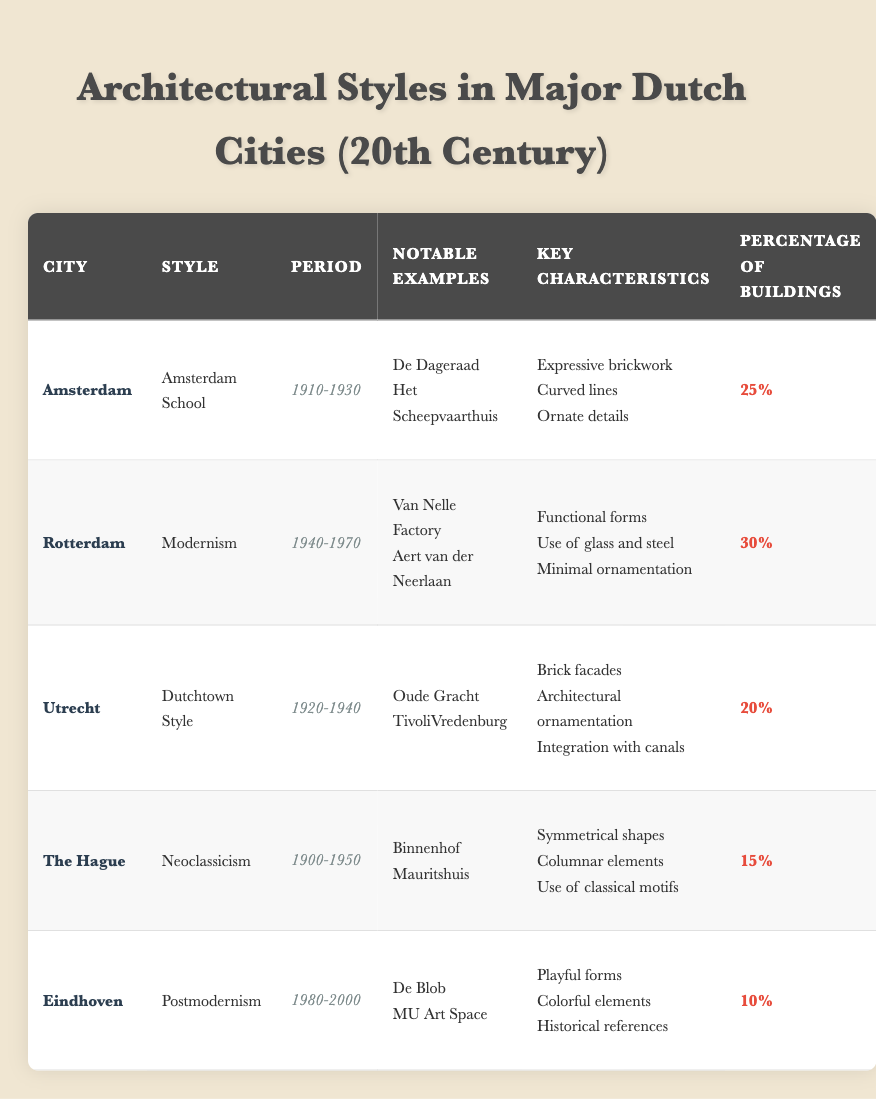What architectural style has the largest percentage of buildings in Rotterdam? The table shows that Modernism, which is the architectural style in Rotterdam, has a percentage of buildings listed as 30%. This is the highest percentage among all listed cities.
Answer: 30% Which city has an architectural style with playful forms? The table indicates that Eindhoven features Postmodernism as its architectural style, which is characterized by playful forms.
Answer: Eindhoven Is the percentage of buildings in The Hague higher than in Utrecht? The table presents The Hague with 15% of buildings and Utrecht with 20%. Since 15% is less than 20%, the answer is no.
Answer: No What are the key characteristics of the Amsterdam School? According to the table, the key characteristics of the Amsterdam School include expressive brickwork, curved lines, and ornate details, which exemplify the style.
Answer: expressive brickwork, curved lines, ornate details Calculate the average percentage of buildings across all architectural styles listed in the table. First, add all the percentages: 25 + 30 + 20 + 15 + 10 = 100. Then, divide by the number of styles, which is 5. So, the average percentage is 100 / 5 = 20%.
Answer: 20% Does Utrecht have notable examples related to canals? The examples listed for Utrecht under the Dutchtown Style include TivoliVredenburg and Oude Gracht, with Oude Gracht explicitly known for its integration with canals, confirming the statement is true.
Answer: Yes Which city has the most notable examples listed for its architectural style? The table does not quantify the number of notable examples but only lists two for each city. Therefore, all cities have the same number of notable examples (2), making it impossible to determine which has the most.
Answer: All cities have the same number (2) What is a defining feature of the Neoclassicism style in The Hague? The defining features of Neoclassicism include symmetrical shapes, columnar elements, and the use of classical motifs, as stated in the table.
Answer: symmetrical shapes, columnar elements, classical motifs Which city's architectural style emphasizes minimal ornamentation? The table shows that the Modernism style in Rotterdam emphasizes minimal ornamentation, as indicated in its key characteristics.
Answer: Rotterdam 